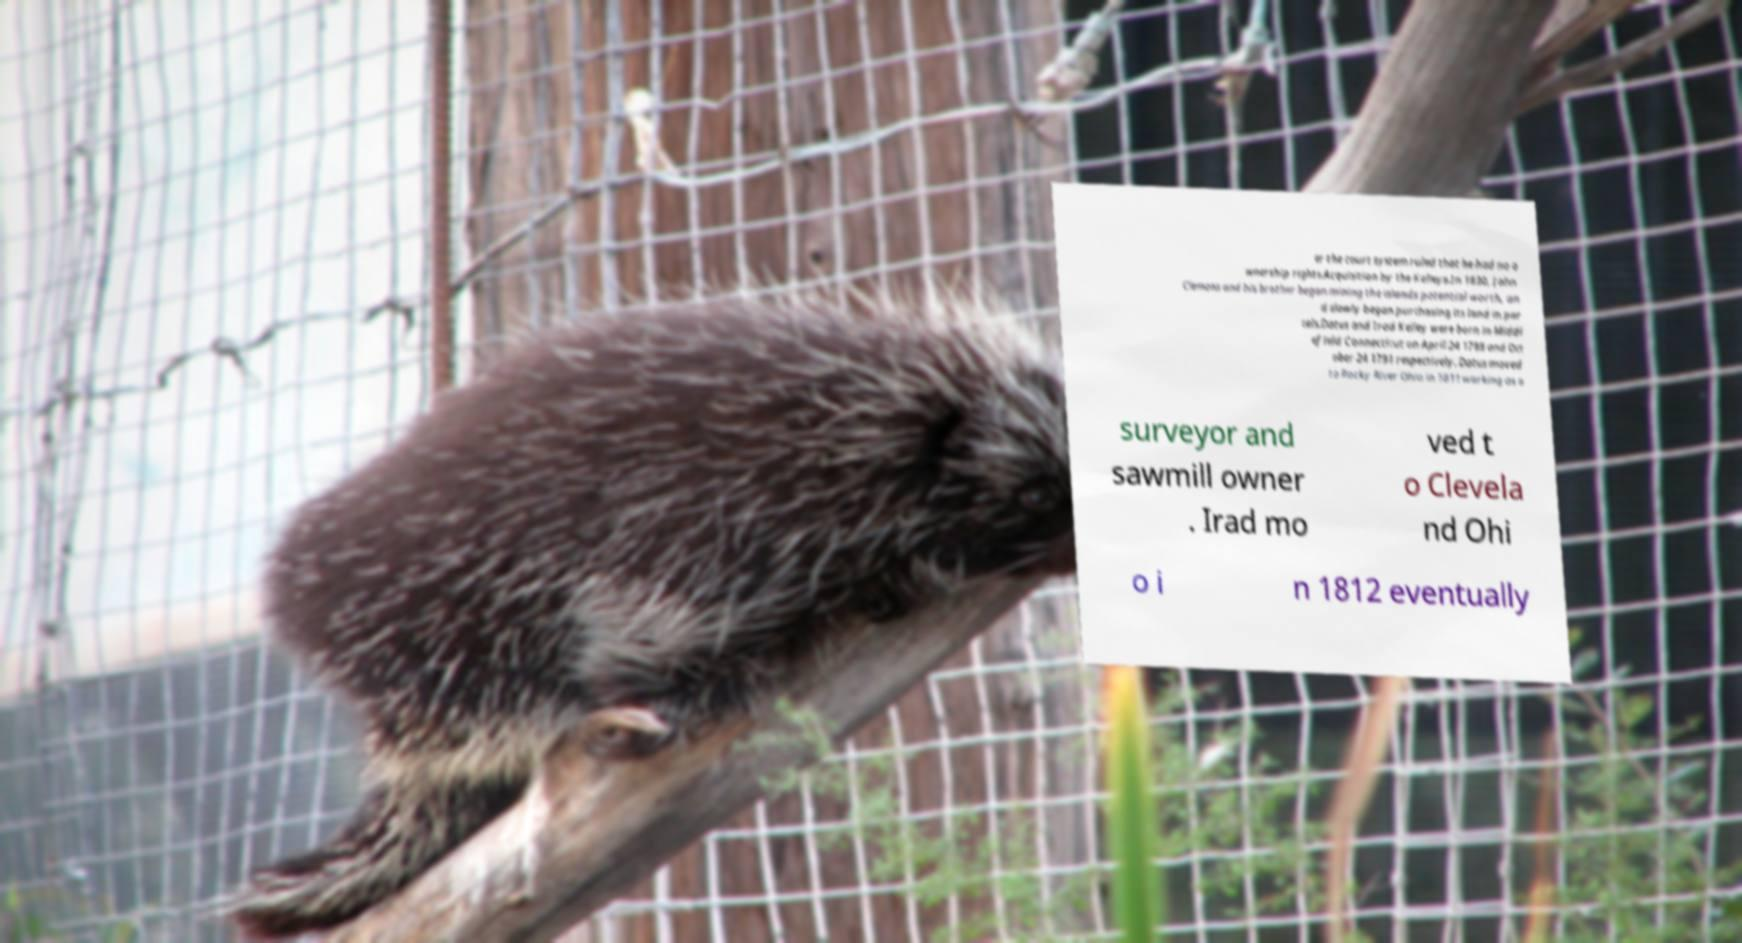There's text embedded in this image that I need extracted. Can you transcribe it verbatim? er the court system ruled that he had no o wnership rights.Acquisition by the Kelleys.In 1830, John Clemons and his brother began mining the islands potential worth, an d slowly began purchasing its land in par cels.Datus and Irad Kelley were born in Middl efield Connecticut on April 24 1788 and Oct ober 24 1791 respectively. Datus moved to Rocky River Ohio in 1811 working as a surveyor and sawmill owner . Irad mo ved t o Clevela nd Ohi o i n 1812 eventually 